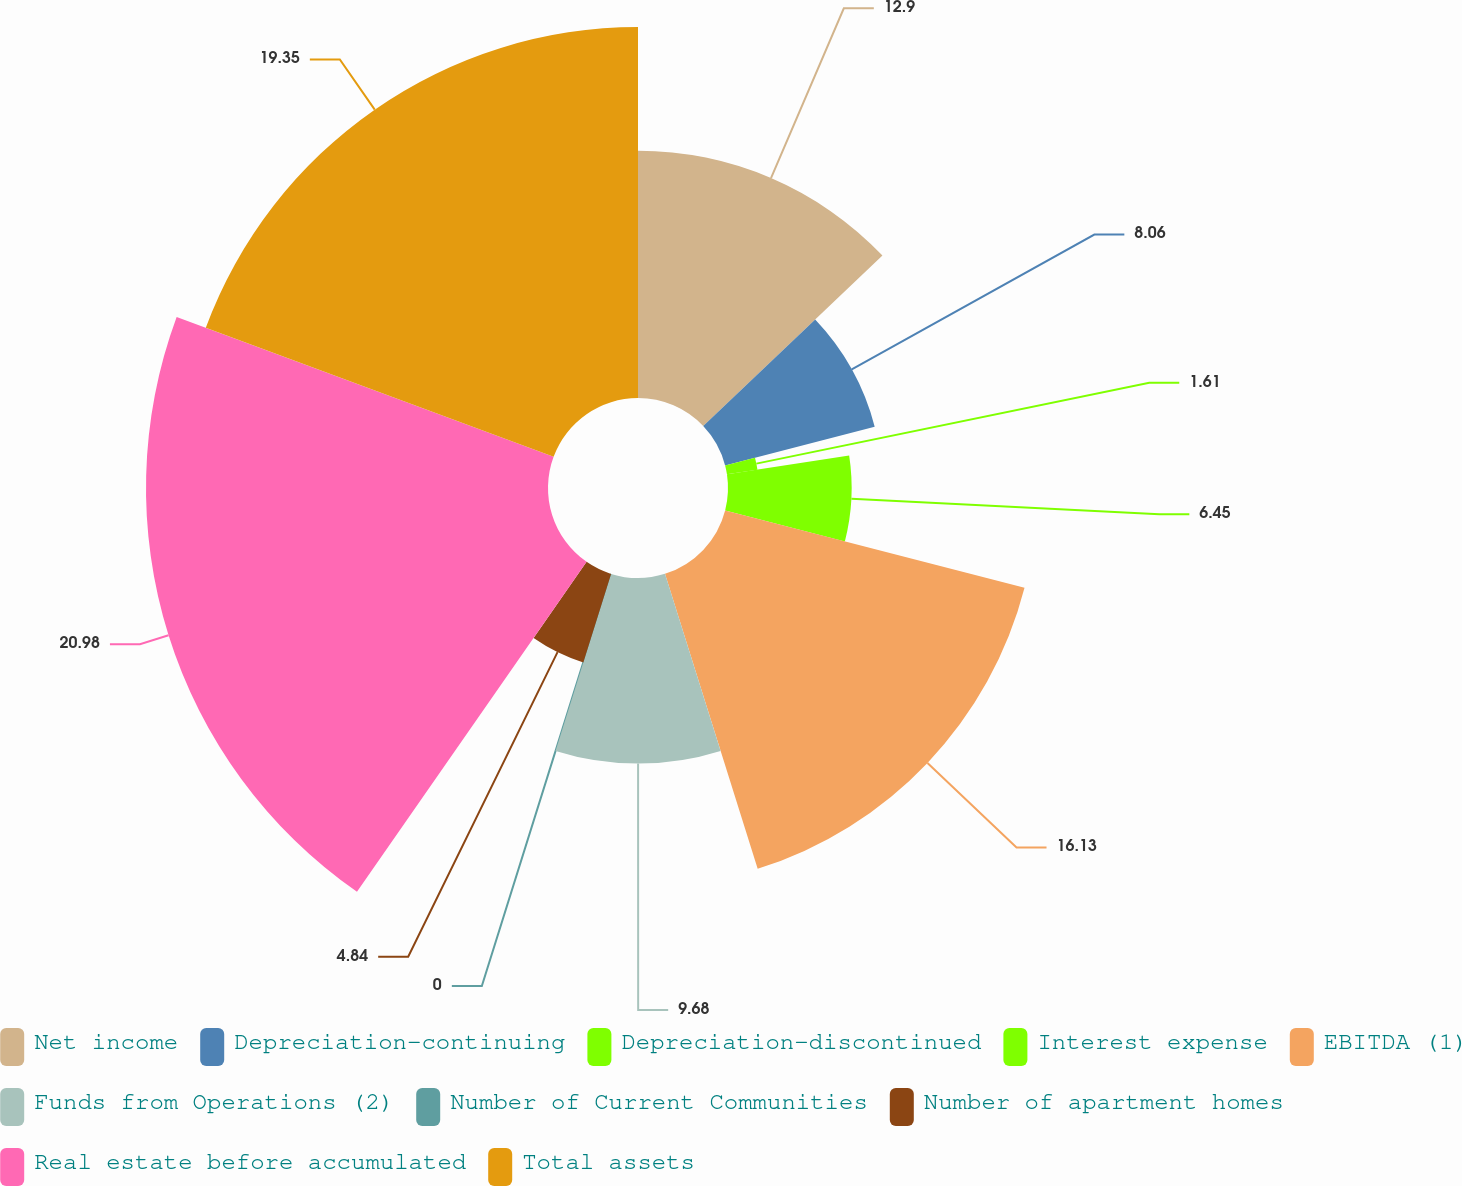<chart> <loc_0><loc_0><loc_500><loc_500><pie_chart><fcel>Net income<fcel>Depreciation-continuing<fcel>Depreciation-discontinued<fcel>Interest expense<fcel>EBITDA (1)<fcel>Funds from Operations (2)<fcel>Number of Current Communities<fcel>Number of apartment homes<fcel>Real estate before accumulated<fcel>Total assets<nl><fcel>12.9%<fcel>8.06%<fcel>1.61%<fcel>6.45%<fcel>16.13%<fcel>9.68%<fcel>0.0%<fcel>4.84%<fcel>20.97%<fcel>19.35%<nl></chart> 